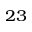<formula> <loc_0><loc_0><loc_500><loc_500>^ { 2 3 }</formula> 